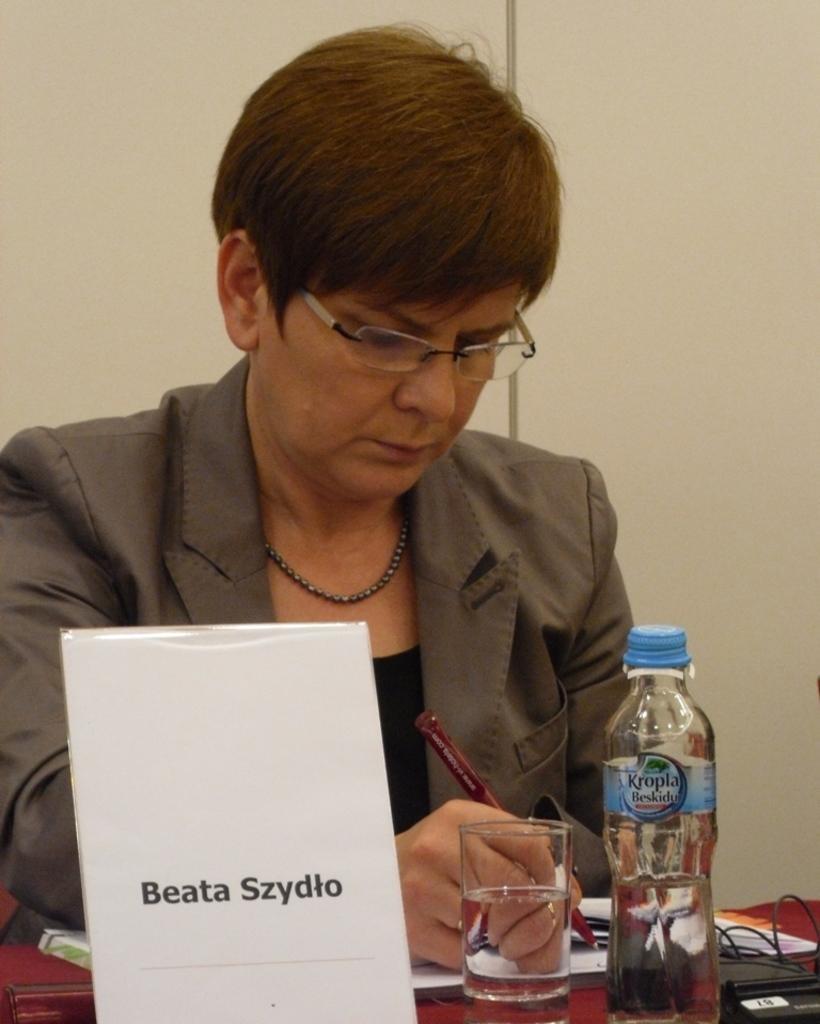How would you summarize this image in a sentence or two? In this image we can see a woman sitting while holding a pen in her hand. We can see glass, bottle, name board and book on the table. 